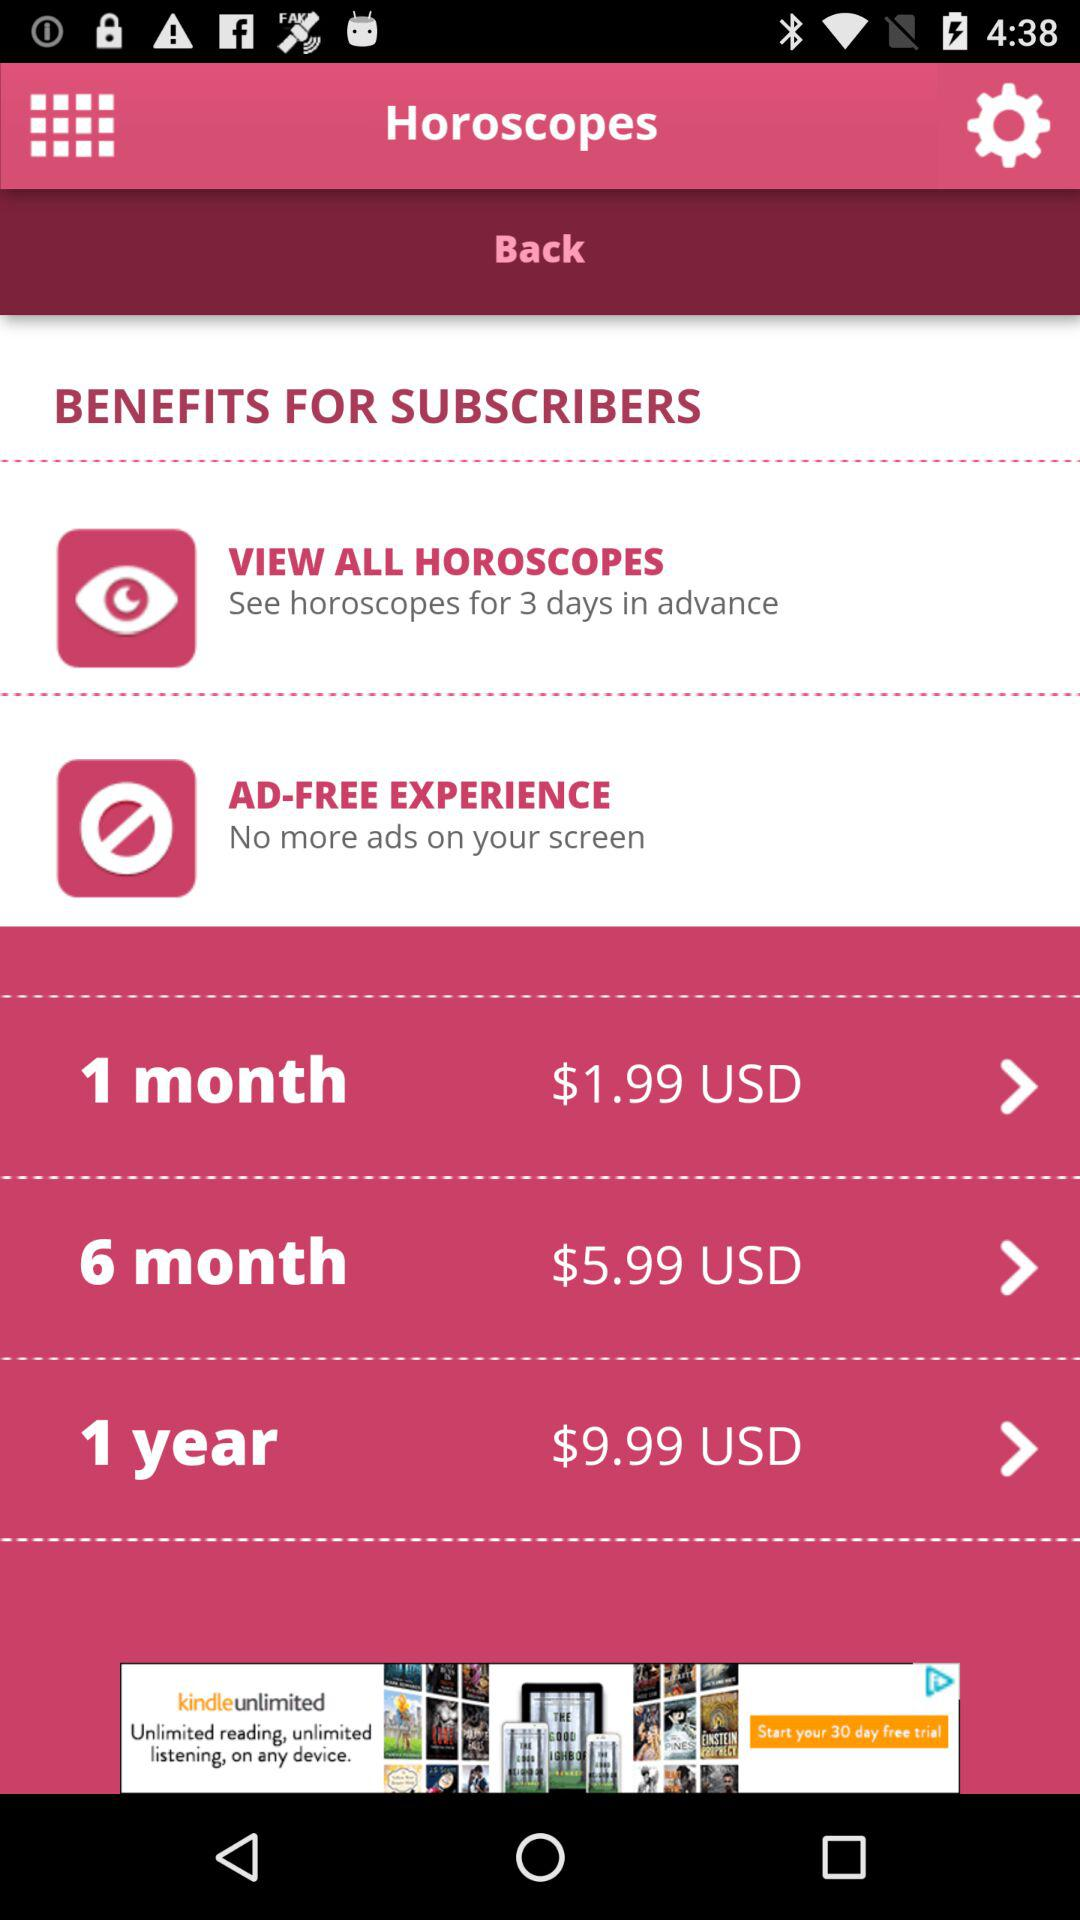For how many days in advance can you see the horoscope? You can see the horoscope for 3 days in advance. 